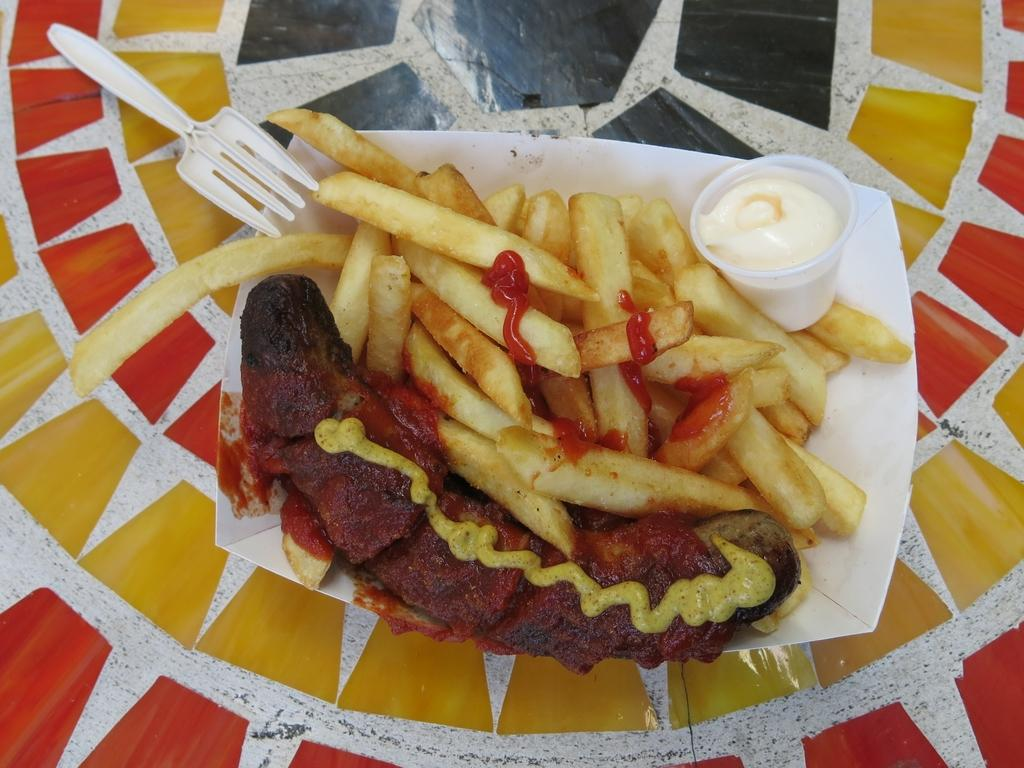What utensil is visible in the image? There is a fork in the image. What type of container is present in the image? There is a glass in the image. What type of food can be seen in the image? There are french fries and a hotdog in the image. What type of verse can be seen on the hotdog in the image? There is no verse present on the hotdog in the image; it is a food item. What type of songs are being sung by the french fries in the image? There are no songs being sung by the french fries in the image; they are a food item. 